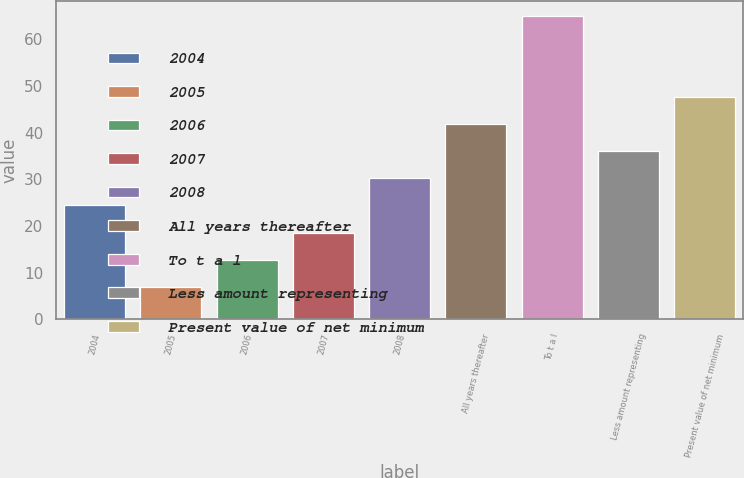Convert chart. <chart><loc_0><loc_0><loc_500><loc_500><bar_chart><fcel>2004<fcel>2005<fcel>2006<fcel>2007<fcel>2008<fcel>All years thereafter<fcel>To t a l<fcel>Less amount representing<fcel>Present value of net minimum<nl><fcel>24.4<fcel>7<fcel>12.8<fcel>18.6<fcel>30.2<fcel>41.8<fcel>65<fcel>36<fcel>47.6<nl></chart> 